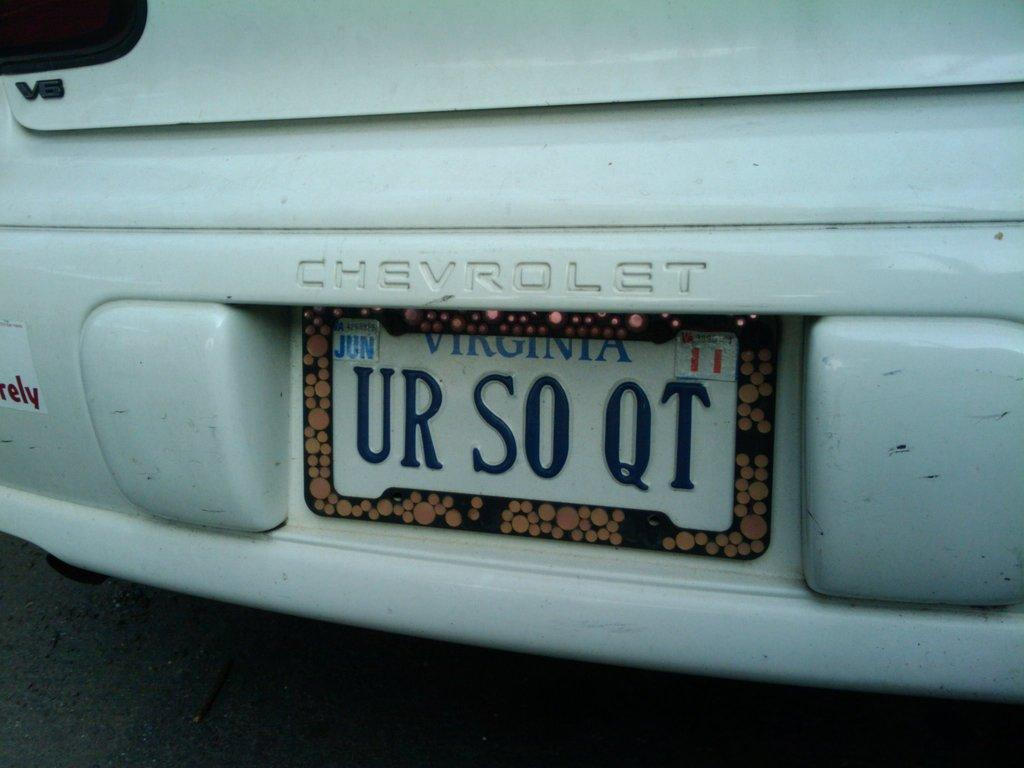<image>
Render a clear and concise summary of the photo. White Chevrolet with a license plate that says UR SO QT. 